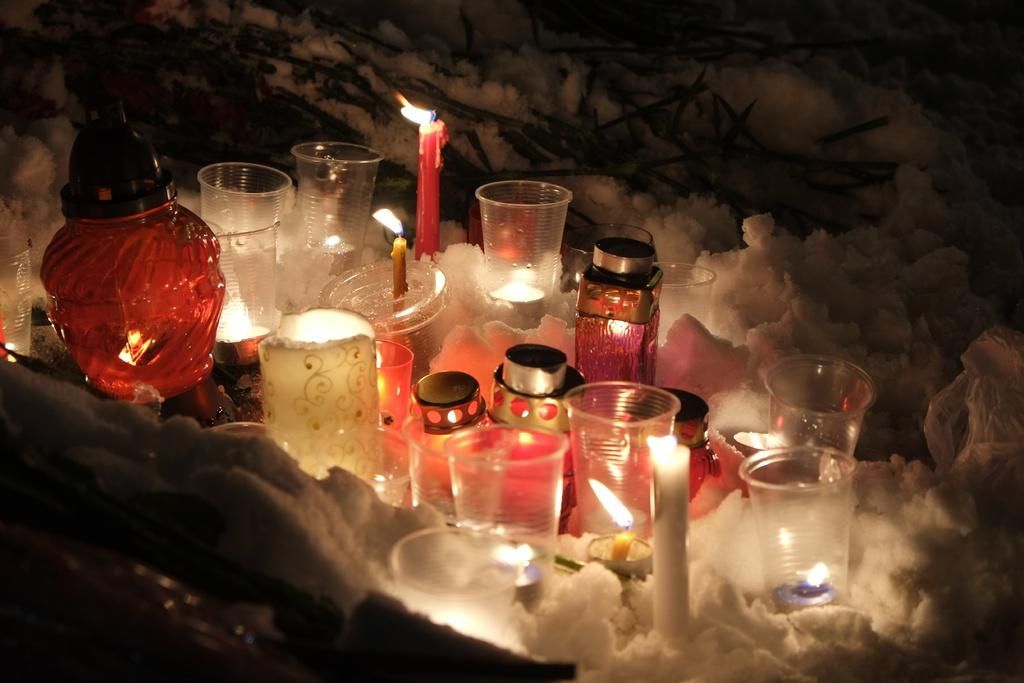What type of containers can be seen in the image? There are glasses, jars, and bottles in the image. What is present in the image that provides light? There are lighted candles in the image. What can be seen at the bottom of the image? There is smoke at the bottom of the image. What type of nerve can be seen in the image? There is no nerve present in the image. What is the tail of the creature in the image? There is no creature with a tail present in the image. 